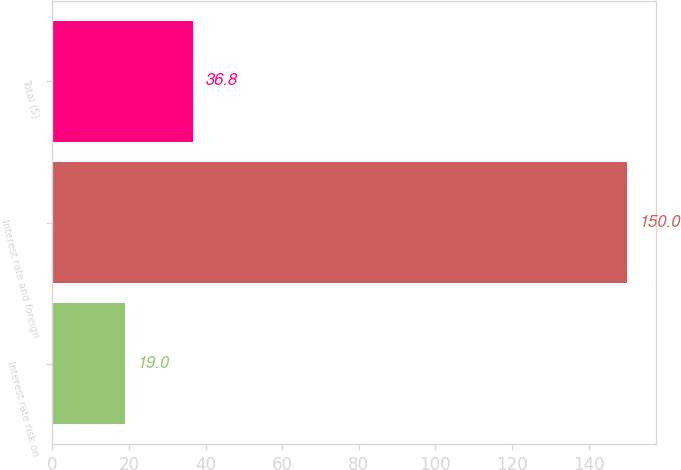Convert chart. <chart><loc_0><loc_0><loc_500><loc_500><bar_chart><fcel>Interest rate risk on<fcel>Interest rate and foreign<fcel>Total (5)<nl><fcel>19<fcel>150<fcel>36.8<nl></chart> 